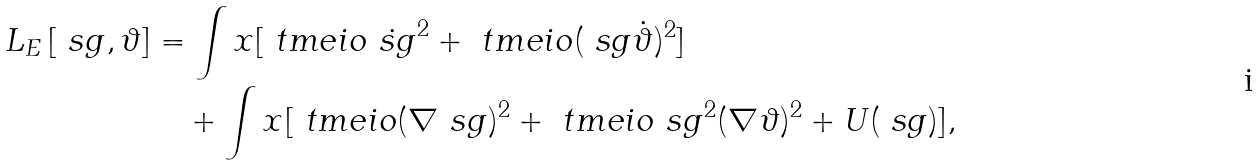Convert formula to latex. <formula><loc_0><loc_0><loc_500><loc_500>L _ { E } \left [ \ s g , \vartheta \right ] & = \int x [ \ t m e i o \dot { \ s g } ^ { 2 } + \ t m e i o ( \ s g \dot { \vartheta } ) ^ { 2 } ] \\ & \quad + \int x [ \ t m e i o ( \nabla \ s g ) ^ { 2 } + \ t m e i o \ s g ^ { 2 } ( \nabla \vartheta ) ^ { 2 } + U ( \ s g ) ] ,</formula> 